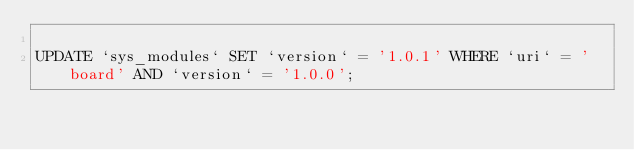Convert code to text. <code><loc_0><loc_0><loc_500><loc_500><_SQL_>
UPDATE `sys_modules` SET `version` = '1.0.1' WHERE `uri` = 'board' AND `version` = '1.0.0';

</code> 